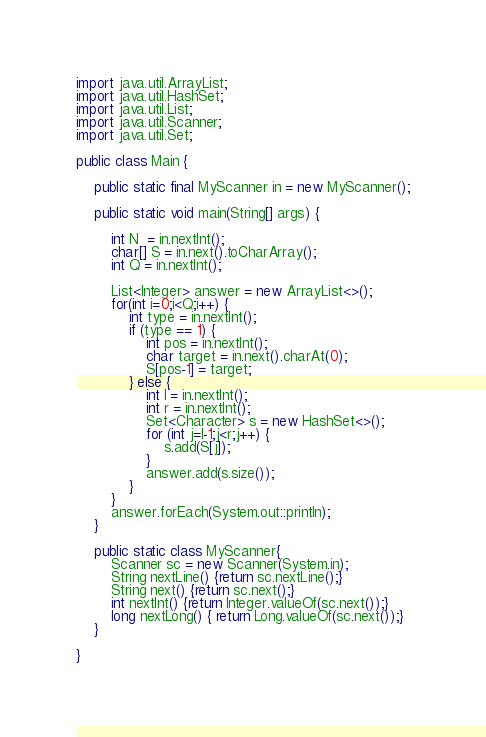<code> <loc_0><loc_0><loc_500><loc_500><_Java_>import java.util.ArrayList;
import java.util.HashSet;
import java.util.List;
import java.util.Scanner;
import java.util.Set;
 
public class Main {
 
	public static final MyScanner in = new MyScanner();
 
	public static void main(String[] args) {
 
		int N  = in.nextInt();
		char[] S = in.next().toCharArray();
		int Q = in.nextInt();

		List<Integer> answer = new ArrayList<>();
		for(int i=0;i<Q;i++) {
			int type = in.nextInt();
			if (type == 1) {
				int pos = in.nextInt();
				char target = in.next().charAt(0);
				S[pos-1] = target;
			} else {
				int l = in.nextInt();
				int r = in.nextInt();
				Set<Character> s = new HashSet<>();
				for (int j=l-1;j<r;j++) {
					s.add(S[j]);
				}
				answer.add(s.size());
			}
		}
		answer.forEach(System.out::println);
	}

	public static class MyScanner{
		Scanner sc = new Scanner(System.in);
		String nextLine() {return sc.nextLine();}
		String next() {return sc.next();}
		int nextInt() {return Integer.valueOf(sc.next());}
		long nextLong() { return Long.valueOf(sc.next());}
	}

}</code> 